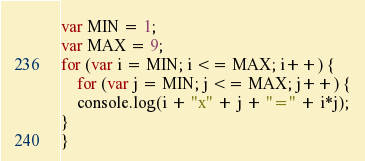Convert code to text. <code><loc_0><loc_0><loc_500><loc_500><_JavaScript_>var MIN = 1;
var MAX = 9;
for (var i = MIN; i <= MAX; i++) {
    for (var j = MIN; j <= MAX; j++) {
    console.log(i + "x" + j + "=" + i*j);
}
}</code> 